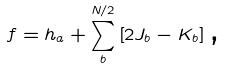Convert formula to latex. <formula><loc_0><loc_0><loc_500><loc_500>f = h _ { a } + \sum _ { b } ^ { N / 2 } \left [ 2 J _ { b } - K _ { b } \right ] \text {,}</formula> 